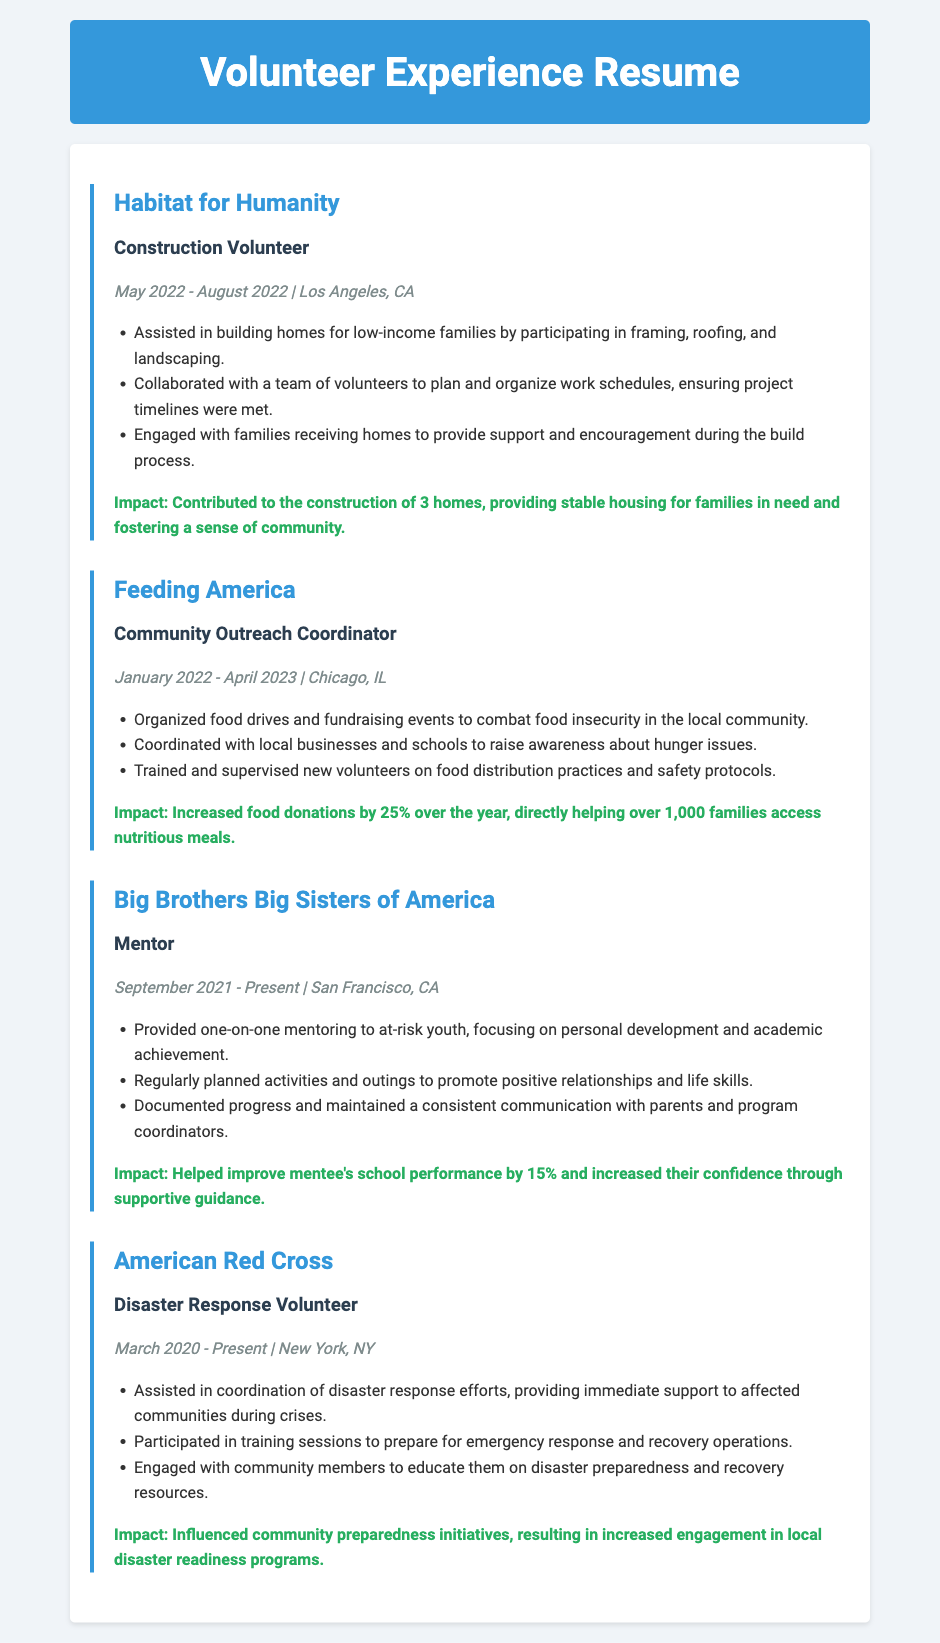What is the role held at Habitat for Humanity? The role is specified under the experience section for Habitat for Humanity, highlighting the specific volunteer position.
Answer: Construction Volunteer When did the volunteer work with Feeding America take place? The dates are provided in the section for Feeding America, indicating the period of service.
Answer: January 2022 - April 2023 How many homes were constructed through Habitat for Humanity? The impact statement for Habitat for Humanity specifies the number of homes constructed as a result of the volunteer work.
Answer: 3 homes What city is Big Brothers Big Sisters of America located in? The location is provided in the experience section for Big Brothers Big Sisters of America.
Answer: San Francisco, CA What percentage did the mentee's school performance improve by? The impact statement for Big Brothers Big Sisters of America indicates the improvement percentage achieved through mentoring.
Answer: 15% What major community issue were food drives organized to combat? The experience section for Feeding America clearly defines the purpose of the food drives that were organized.
Answer: Food insecurity What type of volunteering did the individual do with the American Red Cross? The position held is indicated in the experience section, outlining the nature of the volunteer work.
Answer: Disaster Response Volunteer How many families benefited from the food donations organized by Feeding America? The impact statement for Feeding America quantifies the number of families helped through the initiative.
Answer: Over 1,000 families 